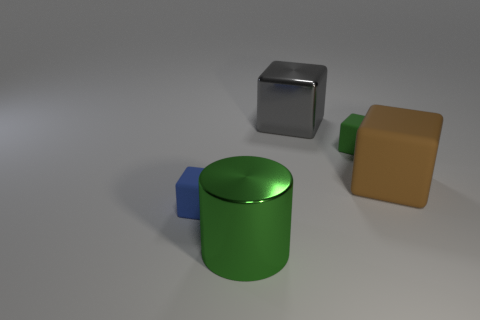Subtract all matte cubes. How many cubes are left? 1 Add 4 big gray metal blocks. How many objects exist? 9 Subtract all gray cubes. How many cubes are left? 3 Subtract all brown cubes. Subtract all red cylinders. How many cubes are left? 3 Subtract all cubes. How many objects are left? 1 Add 1 small gray rubber cylinders. How many small gray rubber cylinders exist? 1 Subtract 0 blue cylinders. How many objects are left? 5 Subtract all large rubber blocks. Subtract all large red rubber blocks. How many objects are left? 4 Add 3 metal cylinders. How many metal cylinders are left? 4 